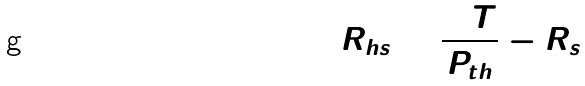<formula> <loc_0><loc_0><loc_500><loc_500>R _ { h s } = \frac { \Delta T } { P _ { t h } } - R _ { s }</formula> 